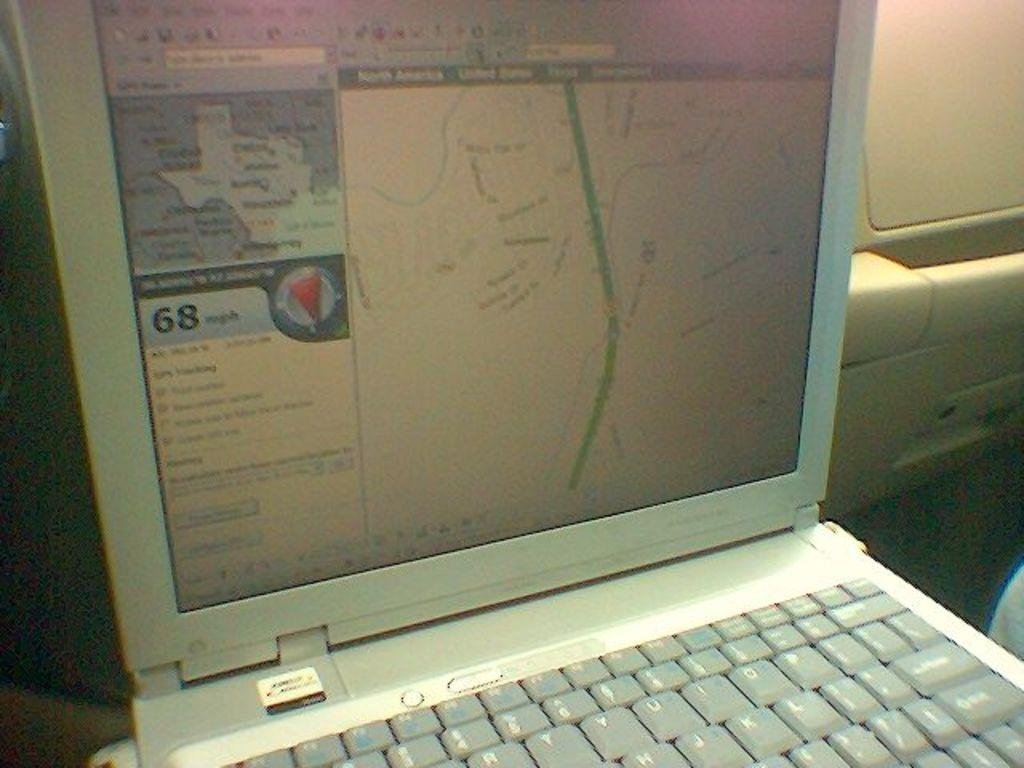<image>
Summarize the visual content of the image. A map that shows a route and the screen says 68 mph 